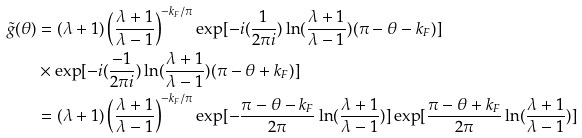<formula> <loc_0><loc_0><loc_500><loc_500>\tilde { g } ( \theta ) & = ( \lambda + 1 ) \left ( \frac { \lambda + 1 } { \lambda - 1 } \right ) ^ { - k _ { F } / \pi } \exp [ - i ( \frac { 1 } { 2 \pi i } ) \ln ( \frac { \lambda + 1 } { \lambda - 1 } ) ( \pi - \theta - k _ { F } ) ] \\ & \times \exp [ - i ( \frac { - 1 } { 2 \pi i } ) \ln ( \frac { \lambda + 1 } { \lambda - 1 } ) ( \pi - \theta + k _ { F } ) ] \\ & = ( \lambda + 1 ) \left ( \frac { \lambda + 1 } { \lambda - 1 } \right ) ^ { - k _ { F } / \pi } \exp [ - \frac { \pi - \theta - k _ { F } } { 2 \pi } \ln ( \frac { \lambda + 1 } { \lambda - 1 } ) ] \exp [ \frac { \pi - \theta + k _ { F } } { 2 \pi } \ln ( \frac { \lambda + 1 } { \lambda - 1 } ) ]</formula> 